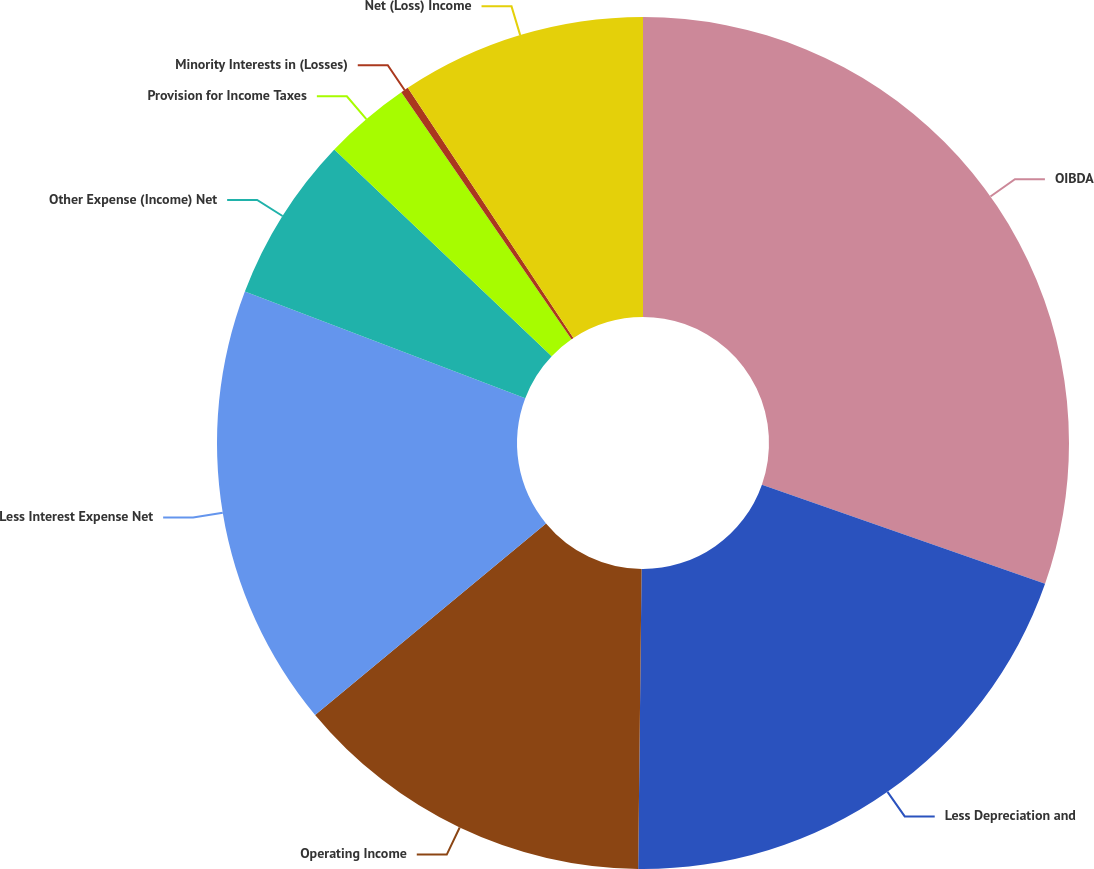Convert chart to OTSL. <chart><loc_0><loc_0><loc_500><loc_500><pie_chart><fcel>OIBDA<fcel>Less Depreciation and<fcel>Operating Income<fcel>Less Interest Expense Net<fcel>Other Expense (Income) Net<fcel>Provision for Income Taxes<fcel>Minority Interests in (Losses)<fcel>Net (Loss) Income<nl><fcel>30.36%<fcel>19.82%<fcel>13.8%<fcel>16.81%<fcel>6.31%<fcel>3.3%<fcel>0.29%<fcel>9.31%<nl></chart> 